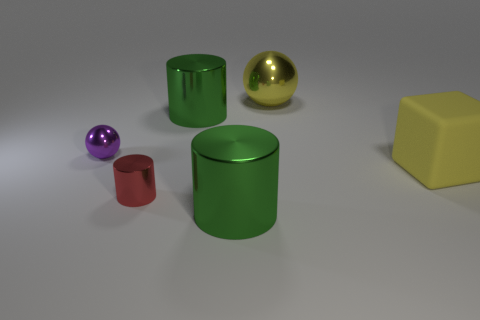Does the yellow thing on the right side of the yellow metallic sphere have the same size as the green metallic thing that is behind the block?
Offer a very short reply. Yes. What number of other things are there of the same shape as the purple object?
Offer a terse response. 1. What material is the object behind the large green shiny cylinder that is behind the purple metallic object made of?
Your answer should be compact. Metal. What number of metal things are green cubes or objects?
Your answer should be compact. 5. Is there any other thing that has the same material as the small purple object?
Make the answer very short. Yes. There is a large green thing that is behind the big matte block; are there any tiny purple objects right of it?
Provide a short and direct response. No. How many things are small shiny objects behind the yellow block or big objects to the left of the yellow metal thing?
Your response must be concise. 3. Are there any other things that are the same color as the tiny sphere?
Make the answer very short. No. What is the color of the big shiny object that is behind the large green metallic cylinder that is left of the large metallic cylinder that is in front of the large yellow rubber cube?
Offer a very short reply. Yellow. There is a thing right of the large yellow metal sphere on the right side of the small red thing; what size is it?
Your answer should be compact. Large. 